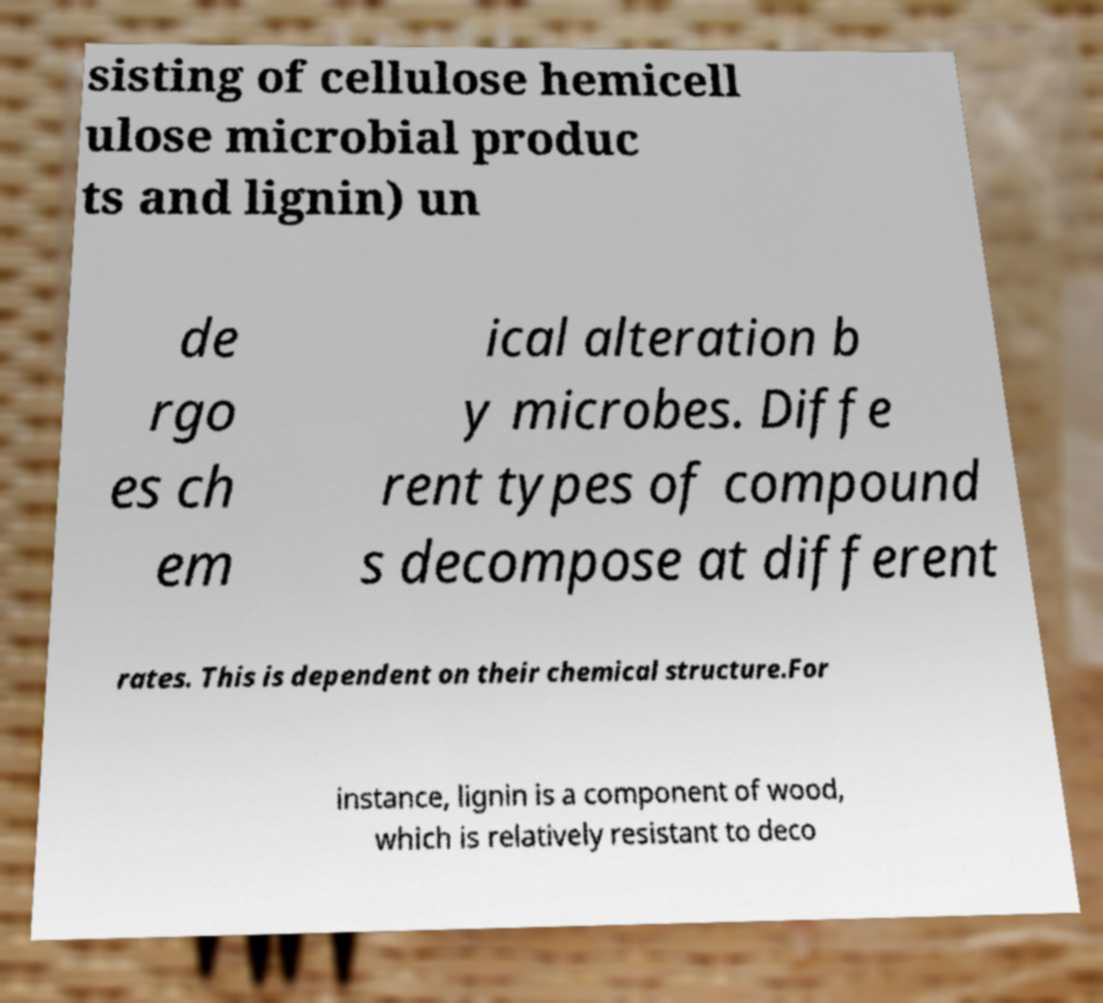What messages or text are displayed in this image? I need them in a readable, typed format. sisting of cellulose hemicell ulose microbial produc ts and lignin) un de rgo es ch em ical alteration b y microbes. Diffe rent types of compound s decompose at different rates. This is dependent on their chemical structure.For instance, lignin is a component of wood, which is relatively resistant to deco 